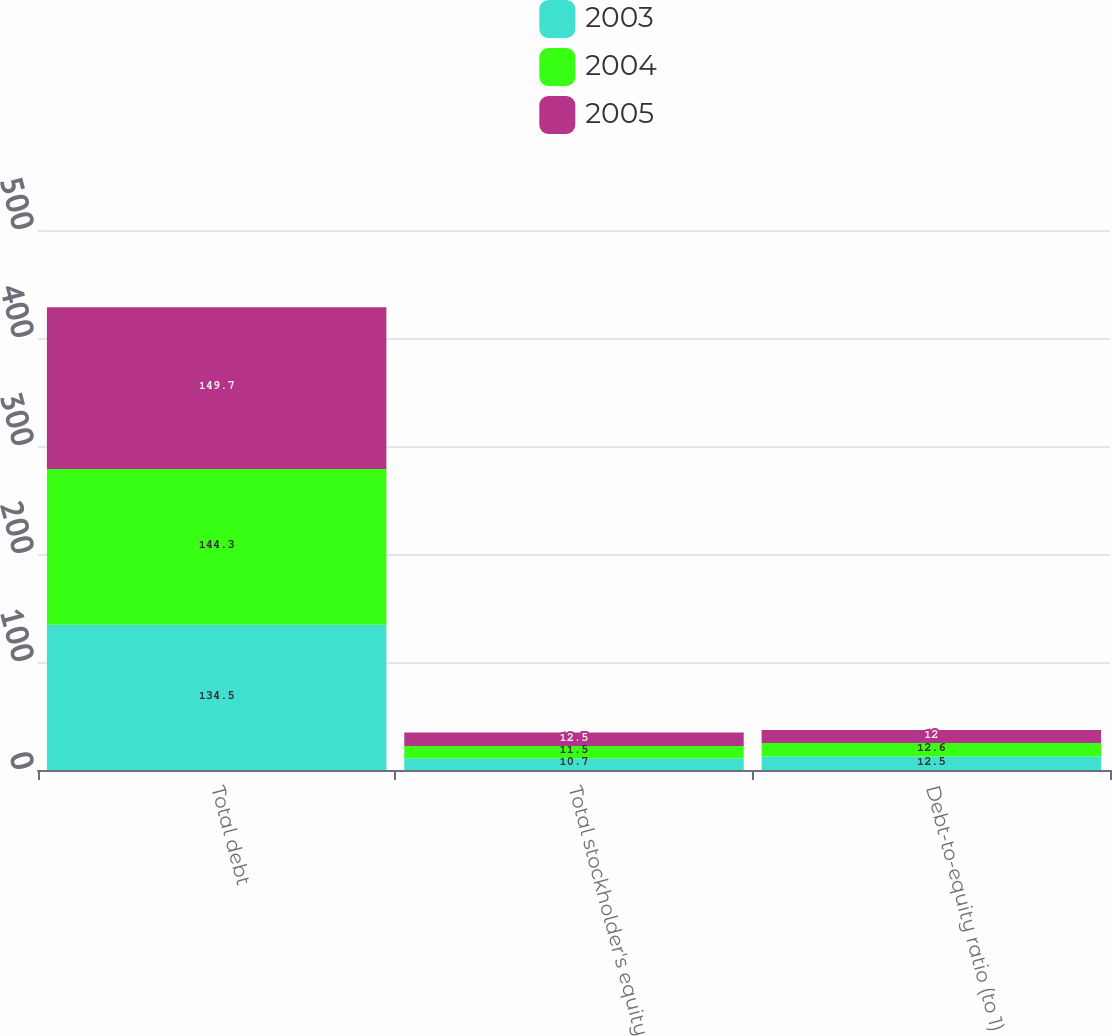<chart> <loc_0><loc_0><loc_500><loc_500><stacked_bar_chart><ecel><fcel>Total debt<fcel>Total stockholder's equity<fcel>Debt-to-equity ratio (to 1)<nl><fcel>2003<fcel>134.5<fcel>10.7<fcel>12.5<nl><fcel>2004<fcel>144.3<fcel>11.5<fcel>12.6<nl><fcel>2005<fcel>149.7<fcel>12.5<fcel>12<nl></chart> 